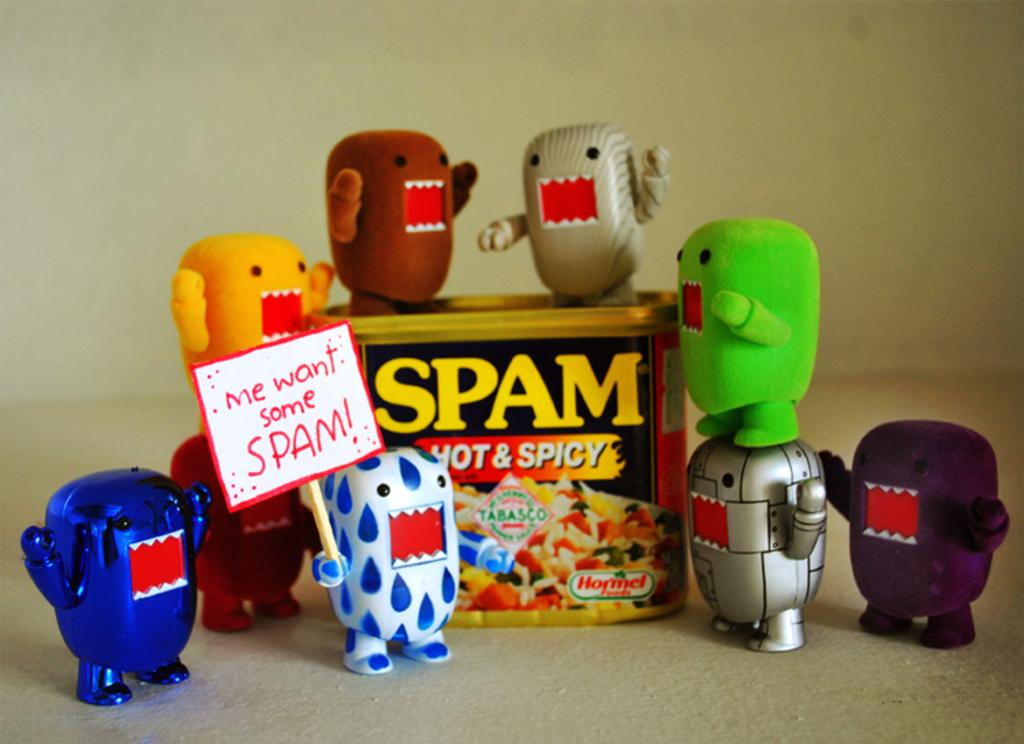What objects can be seen on the table in the image? There are toys on the table in the image. What else is present in the image besides the toys? There is a box in the image. Where are the toys kept when not on the table? The toys are kept in the box. What is a specific action being performed by one of the toys in the image? A toy is holding a banner in the image. What message is written on the banner held by the toy? The banner has the text "Me Want Some Spam!" on it. How many dogs are sitting on the hydrant in the image? There are no dogs or hydrants present in the image; it features toys and a box. 